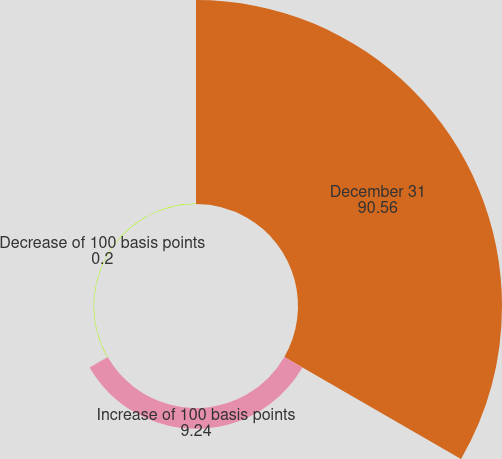<chart> <loc_0><loc_0><loc_500><loc_500><pie_chart><fcel>December 31<fcel>Increase of 100 basis points<fcel>Decrease of 100 basis points<nl><fcel>90.56%<fcel>9.24%<fcel>0.2%<nl></chart> 